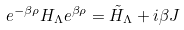<formula> <loc_0><loc_0><loc_500><loc_500>e ^ { - \beta \rho } H _ { \Lambda } e ^ { \beta \rho } = { \tilde { H } } _ { \Lambda } + i \beta J</formula> 